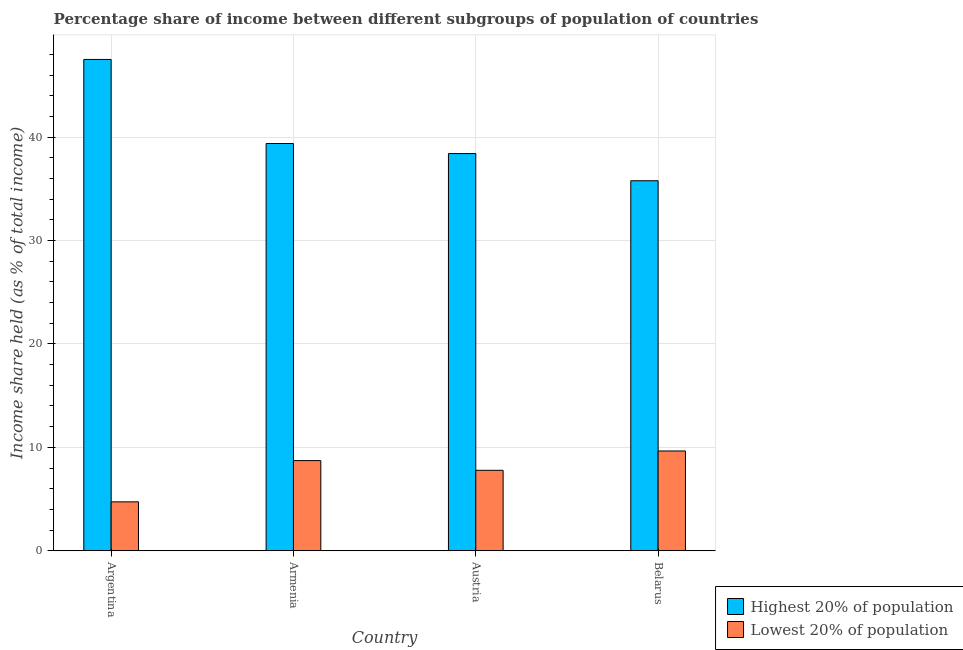How many different coloured bars are there?
Provide a succinct answer. 2. How many groups of bars are there?
Your answer should be compact. 4. Are the number of bars per tick equal to the number of legend labels?
Provide a short and direct response. Yes. How many bars are there on the 4th tick from the left?
Your answer should be compact. 2. How many bars are there on the 1st tick from the right?
Provide a short and direct response. 2. What is the label of the 1st group of bars from the left?
Make the answer very short. Argentina. What is the income share held by lowest 20% of the population in Belarus?
Offer a terse response. 9.65. Across all countries, what is the maximum income share held by highest 20% of the population?
Your answer should be very brief. 47.51. Across all countries, what is the minimum income share held by highest 20% of the population?
Provide a short and direct response. 35.78. In which country was the income share held by highest 20% of the population maximum?
Ensure brevity in your answer.  Argentina. In which country was the income share held by highest 20% of the population minimum?
Your response must be concise. Belarus. What is the total income share held by lowest 20% of the population in the graph?
Offer a very short reply. 30.88. What is the difference between the income share held by lowest 20% of the population in Armenia and that in Belarus?
Your answer should be very brief. -0.93. What is the difference between the income share held by highest 20% of the population in Belarus and the income share held by lowest 20% of the population in Armenia?
Ensure brevity in your answer.  27.06. What is the average income share held by highest 20% of the population per country?
Keep it short and to the point. 40.27. What is the difference between the income share held by lowest 20% of the population and income share held by highest 20% of the population in Armenia?
Your answer should be compact. -30.66. In how many countries, is the income share held by highest 20% of the population greater than 8 %?
Provide a succinct answer. 4. What is the ratio of the income share held by highest 20% of the population in Austria to that in Belarus?
Your answer should be very brief. 1.07. What is the difference between the highest and the second highest income share held by highest 20% of the population?
Ensure brevity in your answer.  8.13. What is the difference between the highest and the lowest income share held by lowest 20% of the population?
Provide a short and direct response. 4.92. In how many countries, is the income share held by lowest 20% of the population greater than the average income share held by lowest 20% of the population taken over all countries?
Give a very brief answer. 3. Is the sum of the income share held by highest 20% of the population in Argentina and Austria greater than the maximum income share held by lowest 20% of the population across all countries?
Provide a succinct answer. Yes. What does the 1st bar from the left in Belarus represents?
Keep it short and to the point. Highest 20% of population. What does the 2nd bar from the right in Argentina represents?
Your response must be concise. Highest 20% of population. How many bars are there?
Give a very brief answer. 8. Are all the bars in the graph horizontal?
Provide a succinct answer. No. How many countries are there in the graph?
Offer a very short reply. 4. What is the difference between two consecutive major ticks on the Y-axis?
Offer a very short reply. 10. Does the graph contain any zero values?
Provide a succinct answer. No. Does the graph contain grids?
Your answer should be compact. Yes. How many legend labels are there?
Give a very brief answer. 2. How are the legend labels stacked?
Give a very brief answer. Vertical. What is the title of the graph?
Provide a short and direct response. Percentage share of income between different subgroups of population of countries. Does "IMF nonconcessional" appear as one of the legend labels in the graph?
Your answer should be compact. No. What is the label or title of the X-axis?
Offer a terse response. Country. What is the label or title of the Y-axis?
Provide a succinct answer. Income share held (as % of total income). What is the Income share held (as % of total income) of Highest 20% of population in Argentina?
Make the answer very short. 47.51. What is the Income share held (as % of total income) in Lowest 20% of population in Argentina?
Offer a very short reply. 4.73. What is the Income share held (as % of total income) of Highest 20% of population in Armenia?
Provide a short and direct response. 39.38. What is the Income share held (as % of total income) in Lowest 20% of population in Armenia?
Ensure brevity in your answer.  8.72. What is the Income share held (as % of total income) in Highest 20% of population in Austria?
Offer a terse response. 38.41. What is the Income share held (as % of total income) in Lowest 20% of population in Austria?
Keep it short and to the point. 7.78. What is the Income share held (as % of total income) in Highest 20% of population in Belarus?
Give a very brief answer. 35.78. What is the Income share held (as % of total income) of Lowest 20% of population in Belarus?
Provide a succinct answer. 9.65. Across all countries, what is the maximum Income share held (as % of total income) of Highest 20% of population?
Ensure brevity in your answer.  47.51. Across all countries, what is the maximum Income share held (as % of total income) in Lowest 20% of population?
Ensure brevity in your answer.  9.65. Across all countries, what is the minimum Income share held (as % of total income) in Highest 20% of population?
Your response must be concise. 35.78. Across all countries, what is the minimum Income share held (as % of total income) of Lowest 20% of population?
Provide a succinct answer. 4.73. What is the total Income share held (as % of total income) of Highest 20% of population in the graph?
Give a very brief answer. 161.08. What is the total Income share held (as % of total income) of Lowest 20% of population in the graph?
Your answer should be very brief. 30.88. What is the difference between the Income share held (as % of total income) in Highest 20% of population in Argentina and that in Armenia?
Offer a very short reply. 8.13. What is the difference between the Income share held (as % of total income) in Lowest 20% of population in Argentina and that in Armenia?
Keep it short and to the point. -3.99. What is the difference between the Income share held (as % of total income) of Lowest 20% of population in Argentina and that in Austria?
Your answer should be compact. -3.05. What is the difference between the Income share held (as % of total income) of Highest 20% of population in Argentina and that in Belarus?
Your answer should be very brief. 11.73. What is the difference between the Income share held (as % of total income) in Lowest 20% of population in Argentina and that in Belarus?
Provide a short and direct response. -4.92. What is the difference between the Income share held (as % of total income) of Lowest 20% of population in Armenia and that in Belarus?
Keep it short and to the point. -0.93. What is the difference between the Income share held (as % of total income) of Highest 20% of population in Austria and that in Belarus?
Provide a succinct answer. 2.63. What is the difference between the Income share held (as % of total income) of Lowest 20% of population in Austria and that in Belarus?
Your answer should be very brief. -1.87. What is the difference between the Income share held (as % of total income) of Highest 20% of population in Argentina and the Income share held (as % of total income) of Lowest 20% of population in Armenia?
Offer a very short reply. 38.79. What is the difference between the Income share held (as % of total income) in Highest 20% of population in Argentina and the Income share held (as % of total income) in Lowest 20% of population in Austria?
Provide a short and direct response. 39.73. What is the difference between the Income share held (as % of total income) in Highest 20% of population in Argentina and the Income share held (as % of total income) in Lowest 20% of population in Belarus?
Your answer should be very brief. 37.86. What is the difference between the Income share held (as % of total income) of Highest 20% of population in Armenia and the Income share held (as % of total income) of Lowest 20% of population in Austria?
Provide a succinct answer. 31.6. What is the difference between the Income share held (as % of total income) in Highest 20% of population in Armenia and the Income share held (as % of total income) in Lowest 20% of population in Belarus?
Ensure brevity in your answer.  29.73. What is the difference between the Income share held (as % of total income) in Highest 20% of population in Austria and the Income share held (as % of total income) in Lowest 20% of population in Belarus?
Your response must be concise. 28.76. What is the average Income share held (as % of total income) in Highest 20% of population per country?
Give a very brief answer. 40.27. What is the average Income share held (as % of total income) in Lowest 20% of population per country?
Your answer should be very brief. 7.72. What is the difference between the Income share held (as % of total income) of Highest 20% of population and Income share held (as % of total income) of Lowest 20% of population in Argentina?
Your answer should be compact. 42.78. What is the difference between the Income share held (as % of total income) in Highest 20% of population and Income share held (as % of total income) in Lowest 20% of population in Armenia?
Ensure brevity in your answer.  30.66. What is the difference between the Income share held (as % of total income) of Highest 20% of population and Income share held (as % of total income) of Lowest 20% of population in Austria?
Give a very brief answer. 30.63. What is the difference between the Income share held (as % of total income) of Highest 20% of population and Income share held (as % of total income) of Lowest 20% of population in Belarus?
Offer a very short reply. 26.13. What is the ratio of the Income share held (as % of total income) in Highest 20% of population in Argentina to that in Armenia?
Make the answer very short. 1.21. What is the ratio of the Income share held (as % of total income) of Lowest 20% of population in Argentina to that in Armenia?
Ensure brevity in your answer.  0.54. What is the ratio of the Income share held (as % of total income) of Highest 20% of population in Argentina to that in Austria?
Offer a terse response. 1.24. What is the ratio of the Income share held (as % of total income) of Lowest 20% of population in Argentina to that in Austria?
Provide a succinct answer. 0.61. What is the ratio of the Income share held (as % of total income) of Highest 20% of population in Argentina to that in Belarus?
Provide a succinct answer. 1.33. What is the ratio of the Income share held (as % of total income) of Lowest 20% of population in Argentina to that in Belarus?
Ensure brevity in your answer.  0.49. What is the ratio of the Income share held (as % of total income) of Highest 20% of population in Armenia to that in Austria?
Offer a very short reply. 1.03. What is the ratio of the Income share held (as % of total income) in Lowest 20% of population in Armenia to that in Austria?
Provide a succinct answer. 1.12. What is the ratio of the Income share held (as % of total income) of Highest 20% of population in Armenia to that in Belarus?
Make the answer very short. 1.1. What is the ratio of the Income share held (as % of total income) of Lowest 20% of population in Armenia to that in Belarus?
Ensure brevity in your answer.  0.9. What is the ratio of the Income share held (as % of total income) of Highest 20% of population in Austria to that in Belarus?
Provide a short and direct response. 1.07. What is the ratio of the Income share held (as % of total income) of Lowest 20% of population in Austria to that in Belarus?
Keep it short and to the point. 0.81. What is the difference between the highest and the second highest Income share held (as % of total income) in Highest 20% of population?
Make the answer very short. 8.13. What is the difference between the highest and the second highest Income share held (as % of total income) of Lowest 20% of population?
Provide a succinct answer. 0.93. What is the difference between the highest and the lowest Income share held (as % of total income) of Highest 20% of population?
Offer a very short reply. 11.73. What is the difference between the highest and the lowest Income share held (as % of total income) in Lowest 20% of population?
Your answer should be compact. 4.92. 